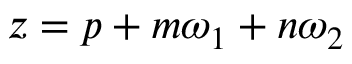Convert formula to latex. <formula><loc_0><loc_0><loc_500><loc_500>z = p + m \omega _ { 1 } + n \omega _ { 2 }</formula> 